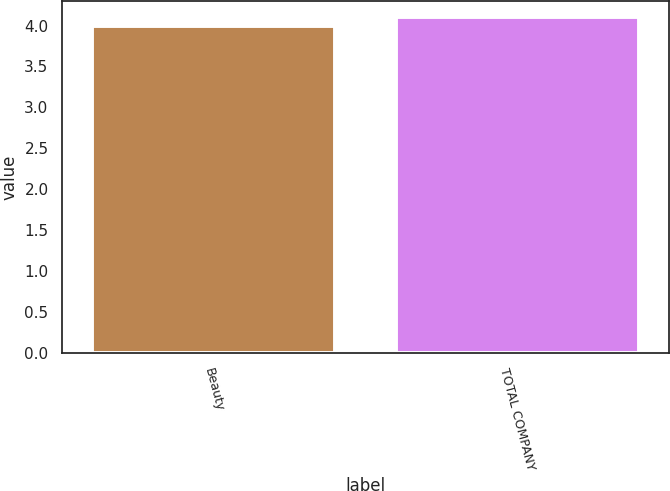<chart> <loc_0><loc_0><loc_500><loc_500><bar_chart><fcel>Beauty<fcel>TOTAL COMPANY<nl><fcel>4<fcel>4.1<nl></chart> 